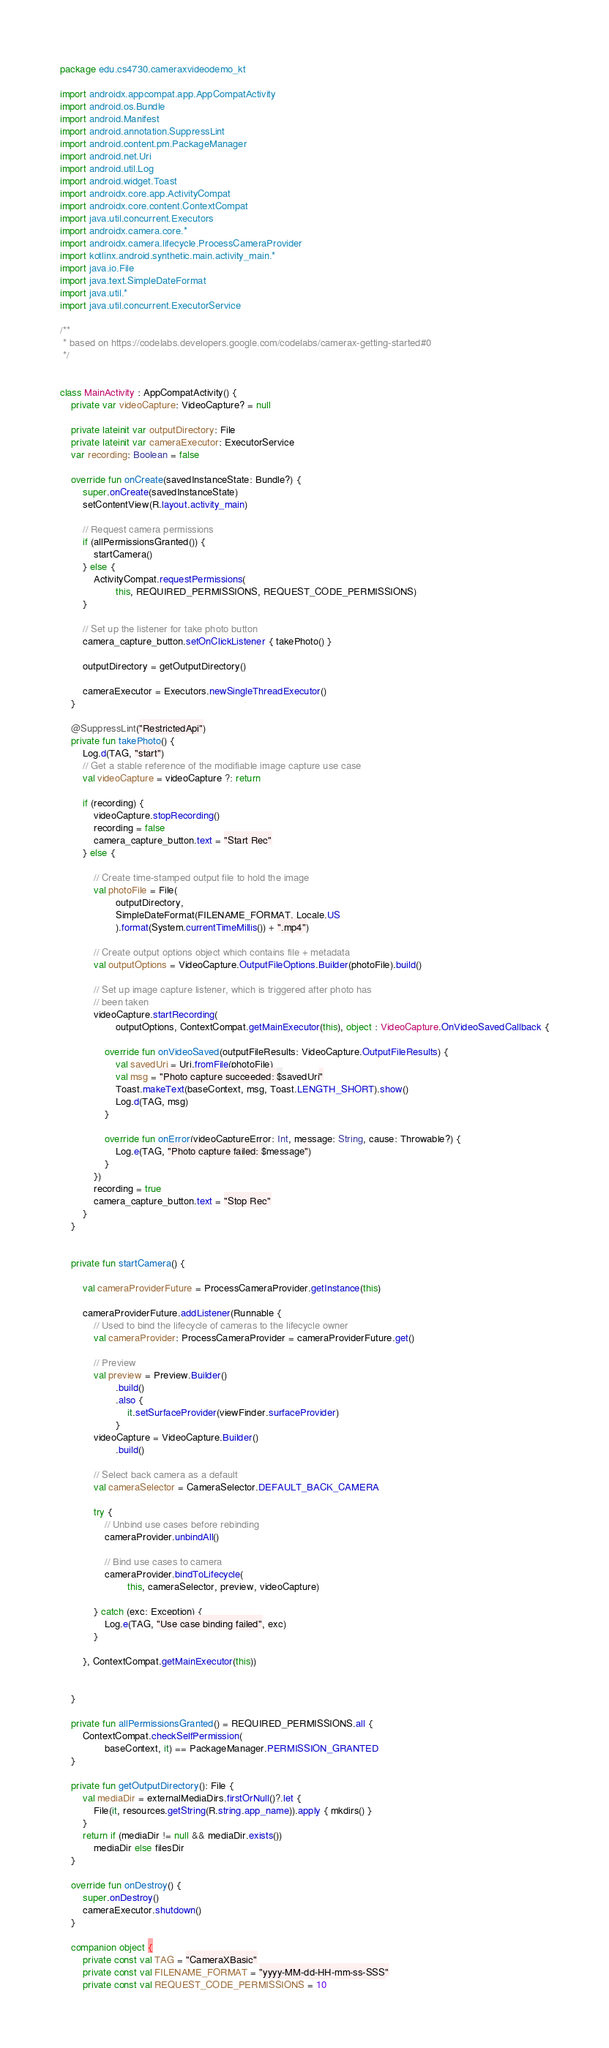Convert code to text. <code><loc_0><loc_0><loc_500><loc_500><_Kotlin_>package edu.cs4730.cameraxvideodemo_kt

import androidx.appcompat.app.AppCompatActivity
import android.os.Bundle
import android.Manifest
import android.annotation.SuppressLint
import android.content.pm.PackageManager
import android.net.Uri
import android.util.Log
import android.widget.Toast
import androidx.core.app.ActivityCompat
import androidx.core.content.ContextCompat
import java.util.concurrent.Executors
import androidx.camera.core.*
import androidx.camera.lifecycle.ProcessCameraProvider
import kotlinx.android.synthetic.main.activity_main.*
import java.io.File
import java.text.SimpleDateFormat
import java.util.*
import java.util.concurrent.ExecutorService

/**
 * based on https://codelabs.developers.google.com/codelabs/camerax-getting-started#0
 */


class MainActivity : AppCompatActivity() {
    private var videoCapture: VideoCapture? = null

    private lateinit var outputDirectory: File
    private lateinit var cameraExecutor: ExecutorService
    var recording: Boolean = false

    override fun onCreate(savedInstanceState: Bundle?) {
        super.onCreate(savedInstanceState)
        setContentView(R.layout.activity_main)

        // Request camera permissions
        if (allPermissionsGranted()) {
            startCamera()
        } else {
            ActivityCompat.requestPermissions(
                    this, REQUIRED_PERMISSIONS, REQUEST_CODE_PERMISSIONS)
        }

        // Set up the listener for take photo button
        camera_capture_button.setOnClickListener { takePhoto() }

        outputDirectory = getOutputDirectory()

        cameraExecutor = Executors.newSingleThreadExecutor()
    }

    @SuppressLint("RestrictedApi")
    private fun takePhoto() {
        Log.d(TAG, "start")
        // Get a stable reference of the modifiable image capture use case
        val videoCapture = videoCapture ?: return

        if (recording) {
            videoCapture.stopRecording()
            recording = false
            camera_capture_button.text = "Start Rec"
        } else {

            // Create time-stamped output file to hold the image
            val photoFile = File(
                    outputDirectory,
                    SimpleDateFormat(FILENAME_FORMAT, Locale.US
                    ).format(System.currentTimeMillis()) + ".mp4")

            // Create output options object which contains file + metadata
            val outputOptions = VideoCapture.OutputFileOptions.Builder(photoFile).build()

            // Set up image capture listener, which is triggered after photo has
            // been taken
            videoCapture.startRecording(
                    outputOptions, ContextCompat.getMainExecutor(this), object : VideoCapture.OnVideoSavedCallback {

                override fun onVideoSaved(outputFileResults: VideoCapture.OutputFileResults) {
                    val savedUri = Uri.fromFile(photoFile)
                    val msg = "Photo capture succeeded: $savedUri"
                    Toast.makeText(baseContext, msg, Toast.LENGTH_SHORT).show()
                    Log.d(TAG, msg)
                }

                override fun onError(videoCaptureError: Int, message: String, cause: Throwable?) {
                    Log.e(TAG, "Photo capture failed: $message")
                }
            })
            recording = true
            camera_capture_button.text = "Stop Rec"
        }
    }


    private fun startCamera() {

        val cameraProviderFuture = ProcessCameraProvider.getInstance(this)

        cameraProviderFuture.addListener(Runnable {
            // Used to bind the lifecycle of cameras to the lifecycle owner
            val cameraProvider: ProcessCameraProvider = cameraProviderFuture.get()

            // Preview
            val preview = Preview.Builder()
                    .build()
                    .also {
                        it.setSurfaceProvider(viewFinder.surfaceProvider)
                    }
            videoCapture = VideoCapture.Builder()
                    .build()

            // Select back camera as a default
            val cameraSelector = CameraSelector.DEFAULT_BACK_CAMERA

            try {
                // Unbind use cases before rebinding
                cameraProvider.unbindAll()

                // Bind use cases to camera
                cameraProvider.bindToLifecycle(
                        this, cameraSelector, preview, videoCapture)

            } catch (exc: Exception) {
                Log.e(TAG, "Use case binding failed", exc)
            }

        }, ContextCompat.getMainExecutor(this))


    }

    private fun allPermissionsGranted() = REQUIRED_PERMISSIONS.all {
        ContextCompat.checkSelfPermission(
                baseContext, it) == PackageManager.PERMISSION_GRANTED
    }

    private fun getOutputDirectory(): File {
        val mediaDir = externalMediaDirs.firstOrNull()?.let {
            File(it, resources.getString(R.string.app_name)).apply { mkdirs() }
        }
        return if (mediaDir != null && mediaDir.exists())
            mediaDir else filesDir
    }

    override fun onDestroy() {
        super.onDestroy()
        cameraExecutor.shutdown()
    }

    companion object {
        private const val TAG = "CameraXBasic"
        private const val FILENAME_FORMAT = "yyyy-MM-dd-HH-mm-ss-SSS"
        private const val REQUEST_CODE_PERMISSIONS = 10</code> 